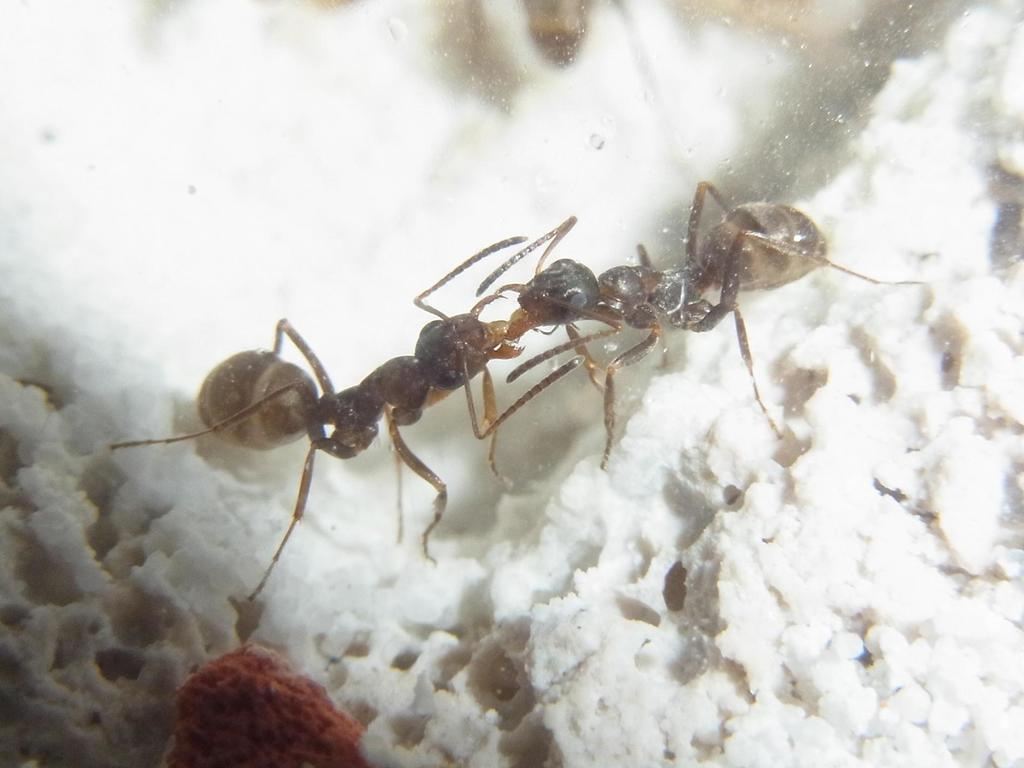What insects can be seen in the image? There are two ants in the image. What surface are the ants on? The ants are on a white object. Can you describe the background of the image? The background of the image is blurred. What type of order is the ants following in the image? There is no indication in the image that the ants are following any specific order. 